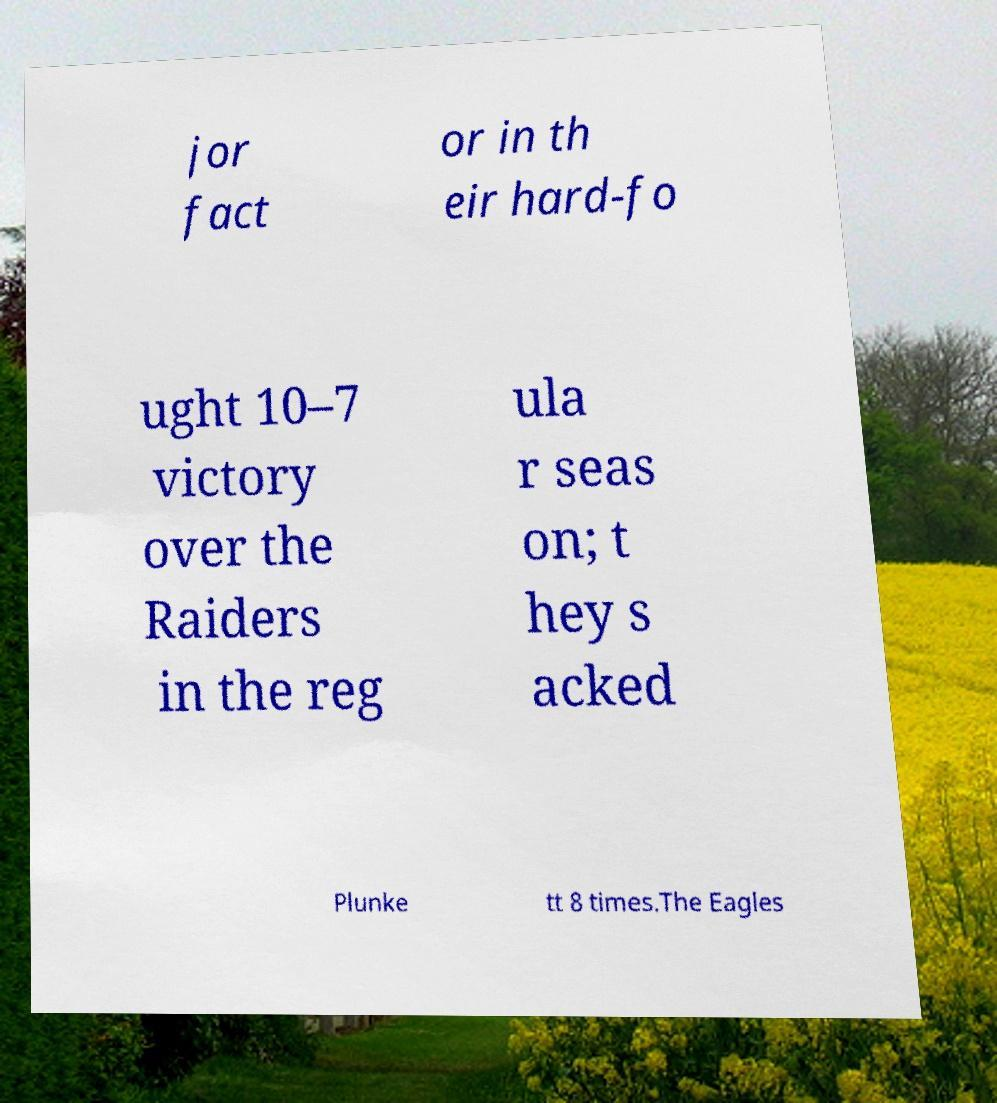Could you extract and type out the text from this image? jor fact or in th eir hard-fo ught 10–7 victory over the Raiders in the reg ula r seas on; t hey s acked Plunke tt 8 times.The Eagles 